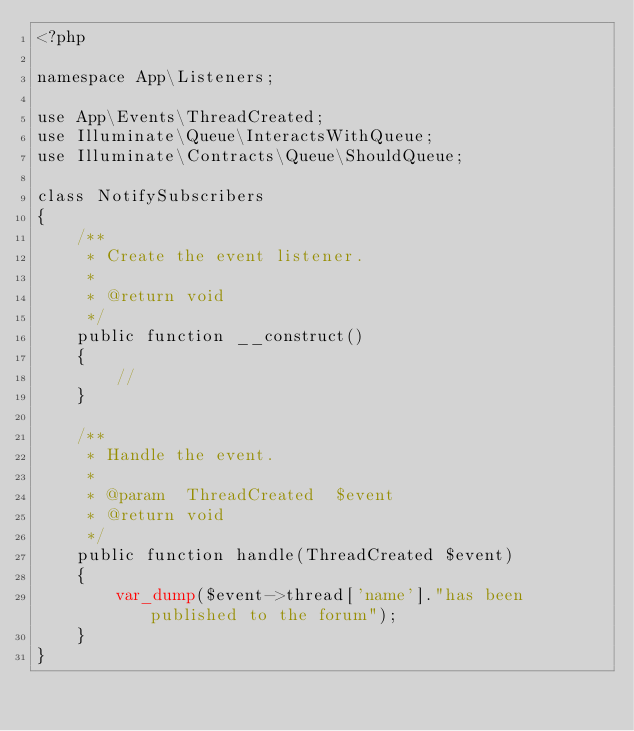<code> <loc_0><loc_0><loc_500><loc_500><_PHP_><?php

namespace App\Listeners;

use App\Events\ThreadCreated;
use Illuminate\Queue\InteractsWithQueue;
use Illuminate\Contracts\Queue\ShouldQueue;

class NotifySubscribers
{
    /**
     * Create the event listener.
     *
     * @return void
     */
    public function __construct()
    {
        //
    }

    /**
     * Handle the event.
     *
     * @param  ThreadCreated  $event
     * @return void
     */
    public function handle(ThreadCreated $event)
    {
        var_dump($event->thread['name']."has been published to the forum");
    }
}
</code> 